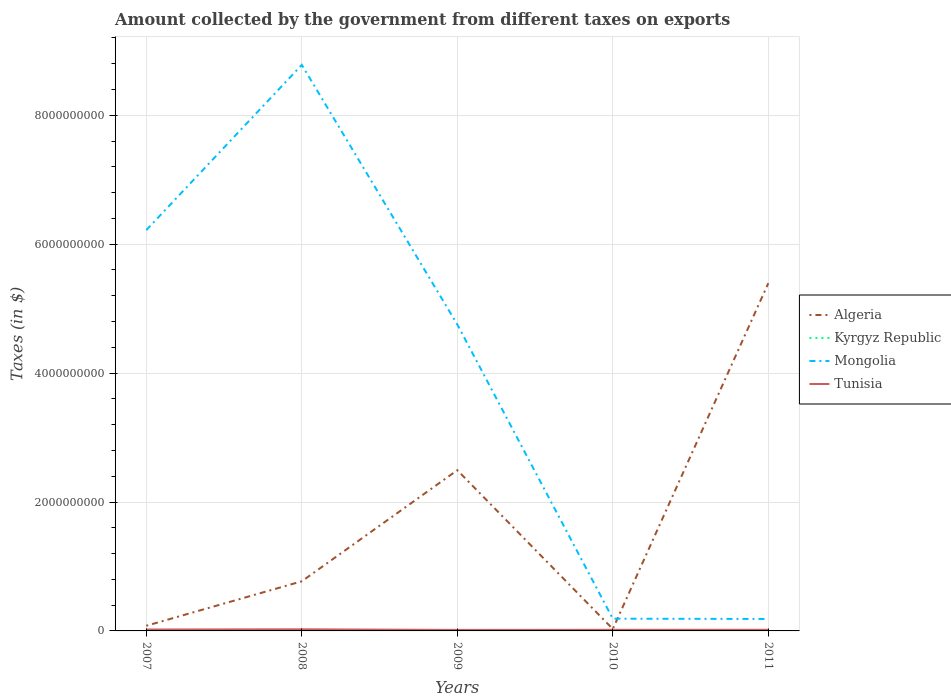Does the line corresponding to Algeria intersect with the line corresponding to Mongolia?
Make the answer very short. Yes. Across all years, what is the maximum amount collected by the government from taxes on exports in Mongolia?
Offer a very short reply. 1.85e+08. What is the difference between the highest and the second highest amount collected by the government from taxes on exports in Tunisia?
Your response must be concise. 9.40e+06. How many lines are there?
Keep it short and to the point. 4. What is the difference between two consecutive major ticks on the Y-axis?
Provide a succinct answer. 2.00e+09. What is the title of the graph?
Provide a short and direct response. Amount collected by the government from different taxes on exports. What is the label or title of the Y-axis?
Your answer should be very brief. Taxes (in $). What is the Taxes (in $) of Algeria in 2007?
Provide a succinct answer. 8.00e+07. What is the Taxes (in $) in Kyrgyz Republic in 2007?
Give a very brief answer. 1.46e+05. What is the Taxes (in $) of Mongolia in 2007?
Keep it short and to the point. 6.22e+09. What is the Taxes (in $) in Tunisia in 2007?
Offer a terse response. 2.21e+07. What is the Taxes (in $) of Algeria in 2008?
Your answer should be compact. 7.70e+08. What is the Taxes (in $) of Kyrgyz Republic in 2008?
Your response must be concise. 1.81e+06. What is the Taxes (in $) of Mongolia in 2008?
Your answer should be very brief. 8.78e+09. What is the Taxes (in $) of Tunisia in 2008?
Your response must be concise. 2.51e+07. What is the Taxes (in $) in Algeria in 2009?
Your answer should be compact. 2.49e+09. What is the Taxes (in $) of Kyrgyz Republic in 2009?
Ensure brevity in your answer.  3.56e+06. What is the Taxes (in $) of Mongolia in 2009?
Provide a short and direct response. 4.75e+09. What is the Taxes (in $) of Tunisia in 2009?
Provide a succinct answer. 1.57e+07. What is the Taxes (in $) of Algeria in 2010?
Keep it short and to the point. 3.00e+07. What is the Taxes (in $) in Kyrgyz Republic in 2010?
Your answer should be compact. 5.91e+06. What is the Taxes (in $) in Mongolia in 2010?
Your answer should be compact. 1.90e+08. What is the Taxes (in $) of Tunisia in 2010?
Provide a succinct answer. 1.75e+07. What is the Taxes (in $) of Algeria in 2011?
Provide a short and direct response. 5.40e+09. What is the Taxes (in $) of Mongolia in 2011?
Your response must be concise. 1.85e+08. What is the Taxes (in $) of Tunisia in 2011?
Your answer should be very brief. 1.80e+07. Across all years, what is the maximum Taxes (in $) in Algeria?
Your answer should be compact. 5.40e+09. Across all years, what is the maximum Taxes (in $) of Kyrgyz Republic?
Your answer should be very brief. 5.91e+06. Across all years, what is the maximum Taxes (in $) of Mongolia?
Give a very brief answer. 8.78e+09. Across all years, what is the maximum Taxes (in $) in Tunisia?
Give a very brief answer. 2.51e+07. Across all years, what is the minimum Taxes (in $) in Algeria?
Offer a very short reply. 3.00e+07. Across all years, what is the minimum Taxes (in $) in Kyrgyz Republic?
Provide a short and direct response. 0. Across all years, what is the minimum Taxes (in $) in Mongolia?
Provide a short and direct response. 1.85e+08. Across all years, what is the minimum Taxes (in $) in Tunisia?
Ensure brevity in your answer.  1.57e+07. What is the total Taxes (in $) of Algeria in the graph?
Make the answer very short. 8.77e+09. What is the total Taxes (in $) of Kyrgyz Republic in the graph?
Offer a very short reply. 1.14e+07. What is the total Taxes (in $) of Mongolia in the graph?
Make the answer very short. 2.01e+1. What is the total Taxes (in $) in Tunisia in the graph?
Make the answer very short. 9.84e+07. What is the difference between the Taxes (in $) of Algeria in 2007 and that in 2008?
Provide a short and direct response. -6.90e+08. What is the difference between the Taxes (in $) of Kyrgyz Republic in 2007 and that in 2008?
Ensure brevity in your answer.  -1.66e+06. What is the difference between the Taxes (in $) in Mongolia in 2007 and that in 2008?
Keep it short and to the point. -2.56e+09. What is the difference between the Taxes (in $) of Tunisia in 2007 and that in 2008?
Keep it short and to the point. -3.00e+06. What is the difference between the Taxes (in $) in Algeria in 2007 and that in 2009?
Provide a short and direct response. -2.41e+09. What is the difference between the Taxes (in $) in Kyrgyz Republic in 2007 and that in 2009?
Keep it short and to the point. -3.42e+06. What is the difference between the Taxes (in $) in Mongolia in 2007 and that in 2009?
Your answer should be very brief. 1.46e+09. What is the difference between the Taxes (in $) in Tunisia in 2007 and that in 2009?
Give a very brief answer. 6.40e+06. What is the difference between the Taxes (in $) in Kyrgyz Republic in 2007 and that in 2010?
Your response must be concise. -5.77e+06. What is the difference between the Taxes (in $) in Mongolia in 2007 and that in 2010?
Provide a short and direct response. 6.03e+09. What is the difference between the Taxes (in $) in Tunisia in 2007 and that in 2010?
Your answer should be very brief. 4.60e+06. What is the difference between the Taxes (in $) in Algeria in 2007 and that in 2011?
Give a very brief answer. -5.32e+09. What is the difference between the Taxes (in $) of Mongolia in 2007 and that in 2011?
Make the answer very short. 6.03e+09. What is the difference between the Taxes (in $) in Tunisia in 2007 and that in 2011?
Your answer should be very brief. 4.10e+06. What is the difference between the Taxes (in $) of Algeria in 2008 and that in 2009?
Provide a succinct answer. -1.72e+09. What is the difference between the Taxes (in $) of Kyrgyz Republic in 2008 and that in 2009?
Offer a terse response. -1.76e+06. What is the difference between the Taxes (in $) in Mongolia in 2008 and that in 2009?
Provide a short and direct response. 4.03e+09. What is the difference between the Taxes (in $) of Tunisia in 2008 and that in 2009?
Your response must be concise. 9.40e+06. What is the difference between the Taxes (in $) of Algeria in 2008 and that in 2010?
Make the answer very short. 7.40e+08. What is the difference between the Taxes (in $) of Kyrgyz Republic in 2008 and that in 2010?
Your response must be concise. -4.11e+06. What is the difference between the Taxes (in $) in Mongolia in 2008 and that in 2010?
Your answer should be very brief. 8.59e+09. What is the difference between the Taxes (in $) of Tunisia in 2008 and that in 2010?
Provide a succinct answer. 7.60e+06. What is the difference between the Taxes (in $) in Algeria in 2008 and that in 2011?
Your answer should be very brief. -4.63e+09. What is the difference between the Taxes (in $) in Mongolia in 2008 and that in 2011?
Make the answer very short. 8.60e+09. What is the difference between the Taxes (in $) in Tunisia in 2008 and that in 2011?
Offer a very short reply. 7.10e+06. What is the difference between the Taxes (in $) in Algeria in 2009 and that in 2010?
Your response must be concise. 2.46e+09. What is the difference between the Taxes (in $) in Kyrgyz Republic in 2009 and that in 2010?
Make the answer very short. -2.35e+06. What is the difference between the Taxes (in $) in Mongolia in 2009 and that in 2010?
Provide a succinct answer. 4.57e+09. What is the difference between the Taxes (in $) of Tunisia in 2009 and that in 2010?
Make the answer very short. -1.80e+06. What is the difference between the Taxes (in $) of Algeria in 2009 and that in 2011?
Keep it short and to the point. -2.90e+09. What is the difference between the Taxes (in $) in Mongolia in 2009 and that in 2011?
Your response must be concise. 4.57e+09. What is the difference between the Taxes (in $) of Tunisia in 2009 and that in 2011?
Offer a very short reply. -2.30e+06. What is the difference between the Taxes (in $) of Algeria in 2010 and that in 2011?
Provide a succinct answer. -5.37e+09. What is the difference between the Taxes (in $) in Mongolia in 2010 and that in 2011?
Ensure brevity in your answer.  4.30e+06. What is the difference between the Taxes (in $) of Tunisia in 2010 and that in 2011?
Keep it short and to the point. -5.00e+05. What is the difference between the Taxes (in $) in Algeria in 2007 and the Taxes (in $) in Kyrgyz Republic in 2008?
Make the answer very short. 7.82e+07. What is the difference between the Taxes (in $) of Algeria in 2007 and the Taxes (in $) of Mongolia in 2008?
Your response must be concise. -8.70e+09. What is the difference between the Taxes (in $) of Algeria in 2007 and the Taxes (in $) of Tunisia in 2008?
Offer a terse response. 5.49e+07. What is the difference between the Taxes (in $) in Kyrgyz Republic in 2007 and the Taxes (in $) in Mongolia in 2008?
Offer a very short reply. -8.78e+09. What is the difference between the Taxes (in $) in Kyrgyz Republic in 2007 and the Taxes (in $) in Tunisia in 2008?
Your answer should be very brief. -2.50e+07. What is the difference between the Taxes (in $) of Mongolia in 2007 and the Taxes (in $) of Tunisia in 2008?
Give a very brief answer. 6.19e+09. What is the difference between the Taxes (in $) of Algeria in 2007 and the Taxes (in $) of Kyrgyz Republic in 2009?
Ensure brevity in your answer.  7.64e+07. What is the difference between the Taxes (in $) in Algeria in 2007 and the Taxes (in $) in Mongolia in 2009?
Your answer should be very brief. -4.67e+09. What is the difference between the Taxes (in $) in Algeria in 2007 and the Taxes (in $) in Tunisia in 2009?
Your answer should be very brief. 6.43e+07. What is the difference between the Taxes (in $) in Kyrgyz Republic in 2007 and the Taxes (in $) in Mongolia in 2009?
Keep it short and to the point. -4.75e+09. What is the difference between the Taxes (in $) in Kyrgyz Republic in 2007 and the Taxes (in $) in Tunisia in 2009?
Your response must be concise. -1.56e+07. What is the difference between the Taxes (in $) of Mongolia in 2007 and the Taxes (in $) of Tunisia in 2009?
Ensure brevity in your answer.  6.20e+09. What is the difference between the Taxes (in $) of Algeria in 2007 and the Taxes (in $) of Kyrgyz Republic in 2010?
Your answer should be very brief. 7.41e+07. What is the difference between the Taxes (in $) of Algeria in 2007 and the Taxes (in $) of Mongolia in 2010?
Your answer should be compact. -1.10e+08. What is the difference between the Taxes (in $) of Algeria in 2007 and the Taxes (in $) of Tunisia in 2010?
Offer a terse response. 6.25e+07. What is the difference between the Taxes (in $) of Kyrgyz Republic in 2007 and the Taxes (in $) of Mongolia in 2010?
Provide a short and direct response. -1.90e+08. What is the difference between the Taxes (in $) in Kyrgyz Republic in 2007 and the Taxes (in $) in Tunisia in 2010?
Your answer should be very brief. -1.74e+07. What is the difference between the Taxes (in $) of Mongolia in 2007 and the Taxes (in $) of Tunisia in 2010?
Give a very brief answer. 6.20e+09. What is the difference between the Taxes (in $) in Algeria in 2007 and the Taxes (in $) in Mongolia in 2011?
Ensure brevity in your answer.  -1.05e+08. What is the difference between the Taxes (in $) of Algeria in 2007 and the Taxes (in $) of Tunisia in 2011?
Offer a terse response. 6.20e+07. What is the difference between the Taxes (in $) of Kyrgyz Republic in 2007 and the Taxes (in $) of Mongolia in 2011?
Provide a short and direct response. -1.85e+08. What is the difference between the Taxes (in $) in Kyrgyz Republic in 2007 and the Taxes (in $) in Tunisia in 2011?
Make the answer very short. -1.79e+07. What is the difference between the Taxes (in $) in Mongolia in 2007 and the Taxes (in $) in Tunisia in 2011?
Your response must be concise. 6.20e+09. What is the difference between the Taxes (in $) in Algeria in 2008 and the Taxes (in $) in Kyrgyz Republic in 2009?
Your answer should be compact. 7.66e+08. What is the difference between the Taxes (in $) in Algeria in 2008 and the Taxes (in $) in Mongolia in 2009?
Offer a very short reply. -3.98e+09. What is the difference between the Taxes (in $) of Algeria in 2008 and the Taxes (in $) of Tunisia in 2009?
Keep it short and to the point. 7.54e+08. What is the difference between the Taxes (in $) of Kyrgyz Republic in 2008 and the Taxes (in $) of Mongolia in 2009?
Provide a succinct answer. -4.75e+09. What is the difference between the Taxes (in $) in Kyrgyz Republic in 2008 and the Taxes (in $) in Tunisia in 2009?
Provide a short and direct response. -1.39e+07. What is the difference between the Taxes (in $) of Mongolia in 2008 and the Taxes (in $) of Tunisia in 2009?
Offer a terse response. 8.77e+09. What is the difference between the Taxes (in $) of Algeria in 2008 and the Taxes (in $) of Kyrgyz Republic in 2010?
Your answer should be compact. 7.64e+08. What is the difference between the Taxes (in $) in Algeria in 2008 and the Taxes (in $) in Mongolia in 2010?
Provide a succinct answer. 5.80e+08. What is the difference between the Taxes (in $) of Algeria in 2008 and the Taxes (in $) of Tunisia in 2010?
Ensure brevity in your answer.  7.52e+08. What is the difference between the Taxes (in $) in Kyrgyz Republic in 2008 and the Taxes (in $) in Mongolia in 2010?
Ensure brevity in your answer.  -1.88e+08. What is the difference between the Taxes (in $) of Kyrgyz Republic in 2008 and the Taxes (in $) of Tunisia in 2010?
Offer a very short reply. -1.57e+07. What is the difference between the Taxes (in $) of Mongolia in 2008 and the Taxes (in $) of Tunisia in 2010?
Your answer should be compact. 8.76e+09. What is the difference between the Taxes (in $) in Algeria in 2008 and the Taxes (in $) in Mongolia in 2011?
Ensure brevity in your answer.  5.85e+08. What is the difference between the Taxes (in $) in Algeria in 2008 and the Taxes (in $) in Tunisia in 2011?
Provide a succinct answer. 7.52e+08. What is the difference between the Taxes (in $) in Kyrgyz Republic in 2008 and the Taxes (in $) in Mongolia in 2011?
Ensure brevity in your answer.  -1.84e+08. What is the difference between the Taxes (in $) of Kyrgyz Republic in 2008 and the Taxes (in $) of Tunisia in 2011?
Keep it short and to the point. -1.62e+07. What is the difference between the Taxes (in $) of Mongolia in 2008 and the Taxes (in $) of Tunisia in 2011?
Your response must be concise. 8.76e+09. What is the difference between the Taxes (in $) of Algeria in 2009 and the Taxes (in $) of Kyrgyz Republic in 2010?
Give a very brief answer. 2.49e+09. What is the difference between the Taxes (in $) in Algeria in 2009 and the Taxes (in $) in Mongolia in 2010?
Offer a terse response. 2.30e+09. What is the difference between the Taxes (in $) of Algeria in 2009 and the Taxes (in $) of Tunisia in 2010?
Offer a terse response. 2.48e+09. What is the difference between the Taxes (in $) of Kyrgyz Republic in 2009 and the Taxes (in $) of Mongolia in 2010?
Give a very brief answer. -1.86e+08. What is the difference between the Taxes (in $) of Kyrgyz Republic in 2009 and the Taxes (in $) of Tunisia in 2010?
Offer a very short reply. -1.39e+07. What is the difference between the Taxes (in $) of Mongolia in 2009 and the Taxes (in $) of Tunisia in 2010?
Provide a short and direct response. 4.74e+09. What is the difference between the Taxes (in $) in Algeria in 2009 and the Taxes (in $) in Mongolia in 2011?
Your answer should be compact. 2.31e+09. What is the difference between the Taxes (in $) of Algeria in 2009 and the Taxes (in $) of Tunisia in 2011?
Ensure brevity in your answer.  2.48e+09. What is the difference between the Taxes (in $) of Kyrgyz Republic in 2009 and the Taxes (in $) of Mongolia in 2011?
Your answer should be very brief. -1.82e+08. What is the difference between the Taxes (in $) of Kyrgyz Republic in 2009 and the Taxes (in $) of Tunisia in 2011?
Make the answer very short. -1.44e+07. What is the difference between the Taxes (in $) of Mongolia in 2009 and the Taxes (in $) of Tunisia in 2011?
Offer a terse response. 4.74e+09. What is the difference between the Taxes (in $) of Algeria in 2010 and the Taxes (in $) of Mongolia in 2011?
Offer a very short reply. -1.55e+08. What is the difference between the Taxes (in $) of Algeria in 2010 and the Taxes (in $) of Tunisia in 2011?
Your answer should be very brief. 1.20e+07. What is the difference between the Taxes (in $) in Kyrgyz Republic in 2010 and the Taxes (in $) in Mongolia in 2011?
Keep it short and to the point. -1.80e+08. What is the difference between the Taxes (in $) of Kyrgyz Republic in 2010 and the Taxes (in $) of Tunisia in 2011?
Provide a short and direct response. -1.21e+07. What is the difference between the Taxes (in $) in Mongolia in 2010 and the Taxes (in $) in Tunisia in 2011?
Keep it short and to the point. 1.72e+08. What is the average Taxes (in $) in Algeria per year?
Provide a short and direct response. 1.75e+09. What is the average Taxes (in $) of Kyrgyz Republic per year?
Provide a succinct answer. 2.29e+06. What is the average Taxes (in $) of Mongolia per year?
Offer a terse response. 4.03e+09. What is the average Taxes (in $) in Tunisia per year?
Give a very brief answer. 1.97e+07. In the year 2007, what is the difference between the Taxes (in $) of Algeria and Taxes (in $) of Kyrgyz Republic?
Keep it short and to the point. 7.99e+07. In the year 2007, what is the difference between the Taxes (in $) in Algeria and Taxes (in $) in Mongolia?
Your response must be concise. -6.14e+09. In the year 2007, what is the difference between the Taxes (in $) in Algeria and Taxes (in $) in Tunisia?
Your response must be concise. 5.79e+07. In the year 2007, what is the difference between the Taxes (in $) of Kyrgyz Republic and Taxes (in $) of Mongolia?
Ensure brevity in your answer.  -6.22e+09. In the year 2007, what is the difference between the Taxes (in $) in Kyrgyz Republic and Taxes (in $) in Tunisia?
Offer a terse response. -2.20e+07. In the year 2007, what is the difference between the Taxes (in $) in Mongolia and Taxes (in $) in Tunisia?
Give a very brief answer. 6.20e+09. In the year 2008, what is the difference between the Taxes (in $) in Algeria and Taxes (in $) in Kyrgyz Republic?
Your response must be concise. 7.68e+08. In the year 2008, what is the difference between the Taxes (in $) in Algeria and Taxes (in $) in Mongolia?
Provide a succinct answer. -8.01e+09. In the year 2008, what is the difference between the Taxes (in $) in Algeria and Taxes (in $) in Tunisia?
Offer a very short reply. 7.45e+08. In the year 2008, what is the difference between the Taxes (in $) in Kyrgyz Republic and Taxes (in $) in Mongolia?
Ensure brevity in your answer.  -8.78e+09. In the year 2008, what is the difference between the Taxes (in $) in Kyrgyz Republic and Taxes (in $) in Tunisia?
Provide a succinct answer. -2.33e+07. In the year 2008, what is the difference between the Taxes (in $) of Mongolia and Taxes (in $) of Tunisia?
Your response must be concise. 8.76e+09. In the year 2009, what is the difference between the Taxes (in $) in Algeria and Taxes (in $) in Kyrgyz Republic?
Ensure brevity in your answer.  2.49e+09. In the year 2009, what is the difference between the Taxes (in $) of Algeria and Taxes (in $) of Mongolia?
Provide a short and direct response. -2.26e+09. In the year 2009, what is the difference between the Taxes (in $) in Algeria and Taxes (in $) in Tunisia?
Ensure brevity in your answer.  2.48e+09. In the year 2009, what is the difference between the Taxes (in $) in Kyrgyz Republic and Taxes (in $) in Mongolia?
Make the answer very short. -4.75e+09. In the year 2009, what is the difference between the Taxes (in $) in Kyrgyz Republic and Taxes (in $) in Tunisia?
Provide a succinct answer. -1.21e+07. In the year 2009, what is the difference between the Taxes (in $) of Mongolia and Taxes (in $) of Tunisia?
Your answer should be compact. 4.74e+09. In the year 2010, what is the difference between the Taxes (in $) in Algeria and Taxes (in $) in Kyrgyz Republic?
Provide a succinct answer. 2.41e+07. In the year 2010, what is the difference between the Taxes (in $) of Algeria and Taxes (in $) of Mongolia?
Provide a short and direct response. -1.60e+08. In the year 2010, what is the difference between the Taxes (in $) in Algeria and Taxes (in $) in Tunisia?
Provide a short and direct response. 1.25e+07. In the year 2010, what is the difference between the Taxes (in $) in Kyrgyz Republic and Taxes (in $) in Mongolia?
Provide a short and direct response. -1.84e+08. In the year 2010, what is the difference between the Taxes (in $) in Kyrgyz Republic and Taxes (in $) in Tunisia?
Make the answer very short. -1.16e+07. In the year 2010, what is the difference between the Taxes (in $) in Mongolia and Taxes (in $) in Tunisia?
Offer a terse response. 1.72e+08. In the year 2011, what is the difference between the Taxes (in $) of Algeria and Taxes (in $) of Mongolia?
Provide a succinct answer. 5.21e+09. In the year 2011, what is the difference between the Taxes (in $) in Algeria and Taxes (in $) in Tunisia?
Offer a terse response. 5.38e+09. In the year 2011, what is the difference between the Taxes (in $) of Mongolia and Taxes (in $) of Tunisia?
Provide a succinct answer. 1.67e+08. What is the ratio of the Taxes (in $) of Algeria in 2007 to that in 2008?
Your answer should be very brief. 0.1. What is the ratio of the Taxes (in $) of Kyrgyz Republic in 2007 to that in 2008?
Your answer should be very brief. 0.08. What is the ratio of the Taxes (in $) of Mongolia in 2007 to that in 2008?
Your response must be concise. 0.71. What is the ratio of the Taxes (in $) in Tunisia in 2007 to that in 2008?
Your answer should be very brief. 0.88. What is the ratio of the Taxes (in $) of Algeria in 2007 to that in 2009?
Keep it short and to the point. 0.03. What is the ratio of the Taxes (in $) in Kyrgyz Republic in 2007 to that in 2009?
Provide a short and direct response. 0.04. What is the ratio of the Taxes (in $) in Mongolia in 2007 to that in 2009?
Ensure brevity in your answer.  1.31. What is the ratio of the Taxes (in $) of Tunisia in 2007 to that in 2009?
Your answer should be very brief. 1.41. What is the ratio of the Taxes (in $) of Algeria in 2007 to that in 2010?
Ensure brevity in your answer.  2.67. What is the ratio of the Taxes (in $) of Kyrgyz Republic in 2007 to that in 2010?
Ensure brevity in your answer.  0.02. What is the ratio of the Taxes (in $) in Mongolia in 2007 to that in 2010?
Offer a very short reply. 32.76. What is the ratio of the Taxes (in $) in Tunisia in 2007 to that in 2010?
Your answer should be very brief. 1.26. What is the ratio of the Taxes (in $) of Algeria in 2007 to that in 2011?
Offer a terse response. 0.01. What is the ratio of the Taxes (in $) in Mongolia in 2007 to that in 2011?
Offer a terse response. 33.52. What is the ratio of the Taxes (in $) of Tunisia in 2007 to that in 2011?
Your response must be concise. 1.23. What is the ratio of the Taxes (in $) in Algeria in 2008 to that in 2009?
Your response must be concise. 0.31. What is the ratio of the Taxes (in $) of Kyrgyz Republic in 2008 to that in 2009?
Your answer should be compact. 0.51. What is the ratio of the Taxes (in $) in Mongolia in 2008 to that in 2009?
Keep it short and to the point. 1.85. What is the ratio of the Taxes (in $) of Tunisia in 2008 to that in 2009?
Keep it short and to the point. 1.6. What is the ratio of the Taxes (in $) of Algeria in 2008 to that in 2010?
Your response must be concise. 25.67. What is the ratio of the Taxes (in $) of Kyrgyz Republic in 2008 to that in 2010?
Ensure brevity in your answer.  0.31. What is the ratio of the Taxes (in $) of Mongolia in 2008 to that in 2010?
Keep it short and to the point. 46.27. What is the ratio of the Taxes (in $) in Tunisia in 2008 to that in 2010?
Your answer should be very brief. 1.43. What is the ratio of the Taxes (in $) in Algeria in 2008 to that in 2011?
Your answer should be compact. 0.14. What is the ratio of the Taxes (in $) of Mongolia in 2008 to that in 2011?
Your answer should be very brief. 47.35. What is the ratio of the Taxes (in $) of Tunisia in 2008 to that in 2011?
Give a very brief answer. 1.39. What is the ratio of the Taxes (in $) in Algeria in 2009 to that in 2010?
Provide a short and direct response. 83.12. What is the ratio of the Taxes (in $) of Kyrgyz Republic in 2009 to that in 2010?
Make the answer very short. 0.6. What is the ratio of the Taxes (in $) of Mongolia in 2009 to that in 2010?
Offer a terse response. 25.05. What is the ratio of the Taxes (in $) in Tunisia in 2009 to that in 2010?
Your answer should be very brief. 0.9. What is the ratio of the Taxes (in $) of Algeria in 2009 to that in 2011?
Provide a short and direct response. 0.46. What is the ratio of the Taxes (in $) of Mongolia in 2009 to that in 2011?
Keep it short and to the point. 25.63. What is the ratio of the Taxes (in $) of Tunisia in 2009 to that in 2011?
Give a very brief answer. 0.87. What is the ratio of the Taxes (in $) of Algeria in 2010 to that in 2011?
Keep it short and to the point. 0.01. What is the ratio of the Taxes (in $) of Mongolia in 2010 to that in 2011?
Offer a very short reply. 1.02. What is the ratio of the Taxes (in $) of Tunisia in 2010 to that in 2011?
Provide a succinct answer. 0.97. What is the difference between the highest and the second highest Taxes (in $) in Algeria?
Your answer should be compact. 2.90e+09. What is the difference between the highest and the second highest Taxes (in $) of Kyrgyz Republic?
Give a very brief answer. 2.35e+06. What is the difference between the highest and the second highest Taxes (in $) of Mongolia?
Keep it short and to the point. 2.56e+09. What is the difference between the highest and the lowest Taxes (in $) in Algeria?
Your response must be concise. 5.37e+09. What is the difference between the highest and the lowest Taxes (in $) of Kyrgyz Republic?
Keep it short and to the point. 5.91e+06. What is the difference between the highest and the lowest Taxes (in $) in Mongolia?
Offer a very short reply. 8.60e+09. What is the difference between the highest and the lowest Taxes (in $) in Tunisia?
Provide a succinct answer. 9.40e+06. 